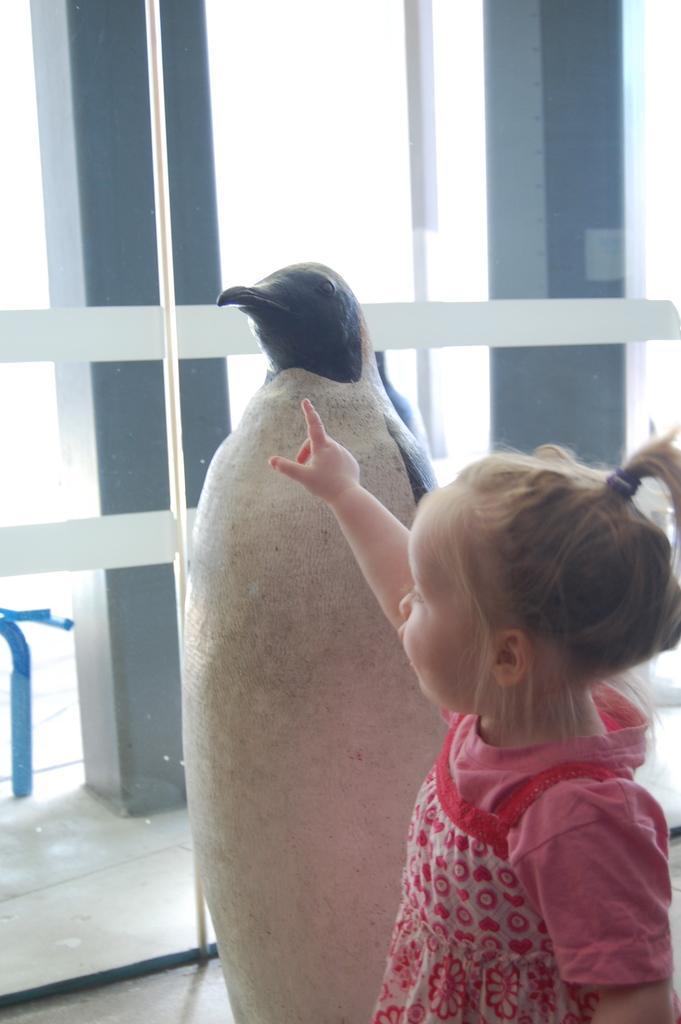In one or two sentences, can you explain what this image depicts? In this image, we can see small girl standing and we can see a statue. 